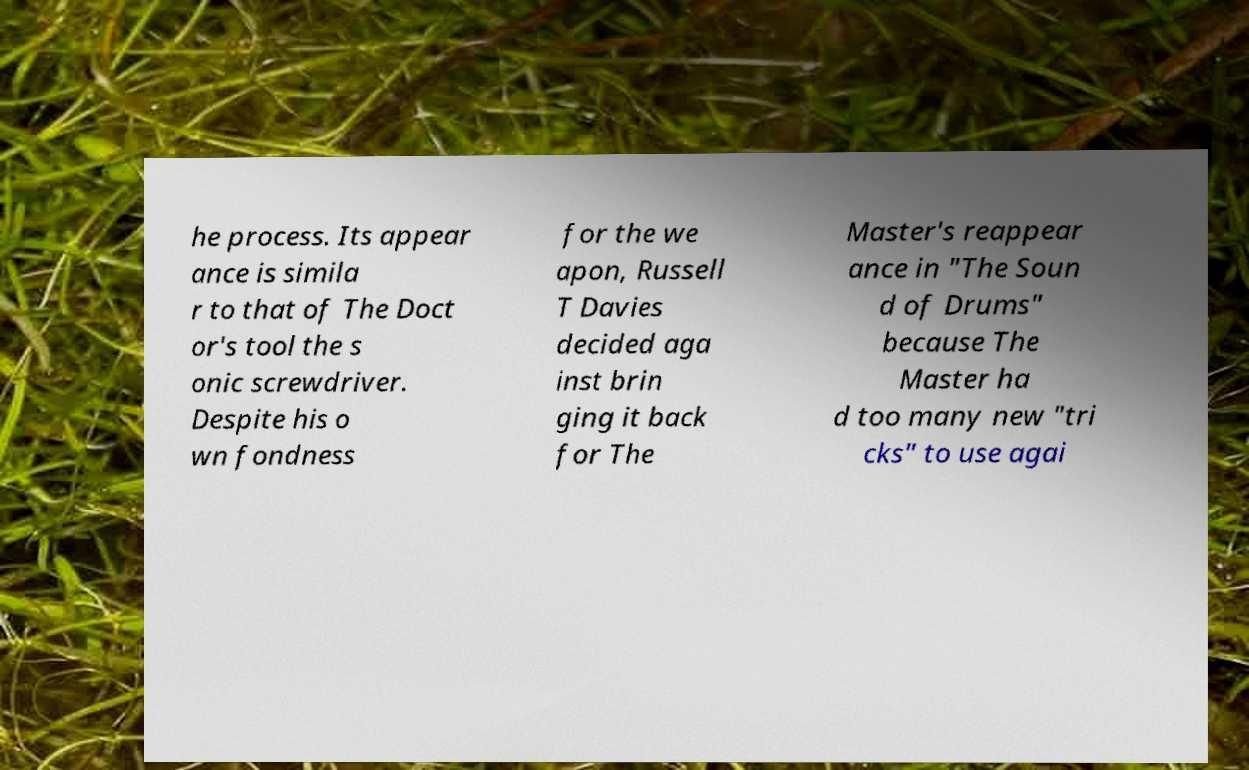For documentation purposes, I need the text within this image transcribed. Could you provide that? he process. Its appear ance is simila r to that of The Doct or's tool the s onic screwdriver. Despite his o wn fondness for the we apon, Russell T Davies decided aga inst brin ging it back for The Master's reappear ance in "The Soun d of Drums" because The Master ha d too many new "tri cks" to use agai 